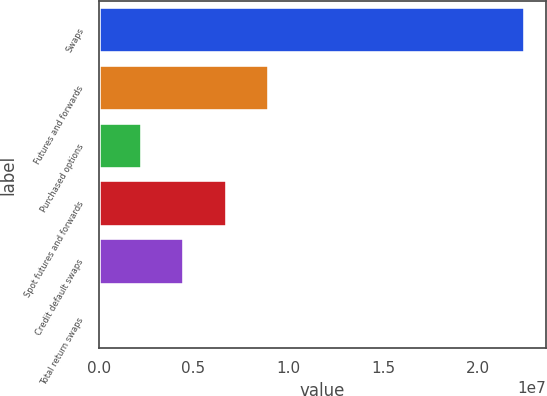Convert chart. <chart><loc_0><loc_0><loc_500><loc_500><bar_chart><fcel>Swaps<fcel>Futures and forwards<fcel>Purchased options<fcel>Spot futures and forwards<fcel>Credit default swaps<fcel>Total return swaps<nl><fcel>2.24729e+07<fcel>8.99731e+06<fcel>2.25949e+06<fcel>6.75137e+06<fcel>4.50543e+06<fcel>13551<nl></chart> 